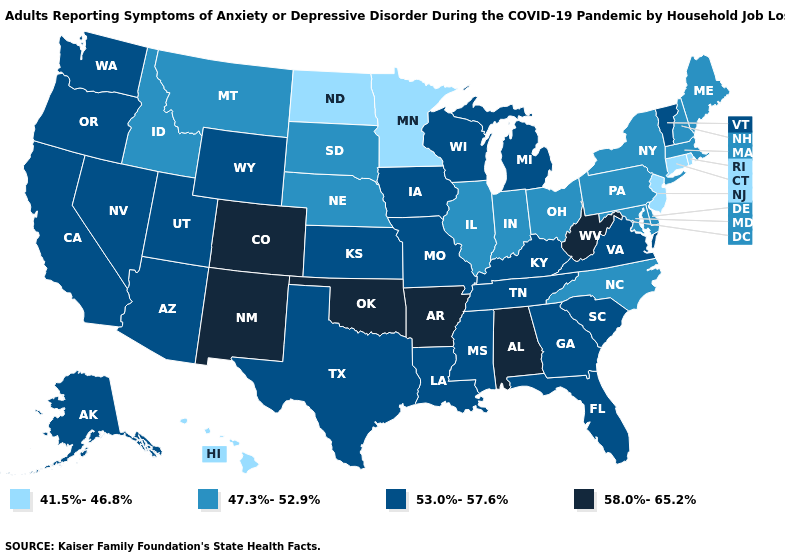What is the highest value in states that border Iowa?
Answer briefly. 53.0%-57.6%. Which states hav the highest value in the MidWest?
Concise answer only. Iowa, Kansas, Michigan, Missouri, Wisconsin. Among the states that border New York , does Vermont have the highest value?
Write a very short answer. Yes. What is the value of Oklahoma?
Be succinct. 58.0%-65.2%. Name the states that have a value in the range 53.0%-57.6%?
Answer briefly. Alaska, Arizona, California, Florida, Georgia, Iowa, Kansas, Kentucky, Louisiana, Michigan, Mississippi, Missouri, Nevada, Oregon, South Carolina, Tennessee, Texas, Utah, Vermont, Virginia, Washington, Wisconsin, Wyoming. What is the value of Maryland?
Concise answer only. 47.3%-52.9%. What is the value of Colorado?
Keep it brief. 58.0%-65.2%. Among the states that border Massachusetts , which have the lowest value?
Concise answer only. Connecticut, Rhode Island. What is the highest value in the USA?
Quick response, please. 58.0%-65.2%. What is the value of Missouri?
Write a very short answer. 53.0%-57.6%. Does the first symbol in the legend represent the smallest category?
Give a very brief answer. Yes. Name the states that have a value in the range 41.5%-46.8%?
Short answer required. Connecticut, Hawaii, Minnesota, New Jersey, North Dakota, Rhode Island. Does the map have missing data?
Keep it brief. No. Is the legend a continuous bar?
Quick response, please. No. How many symbols are there in the legend?
Answer briefly. 4. 